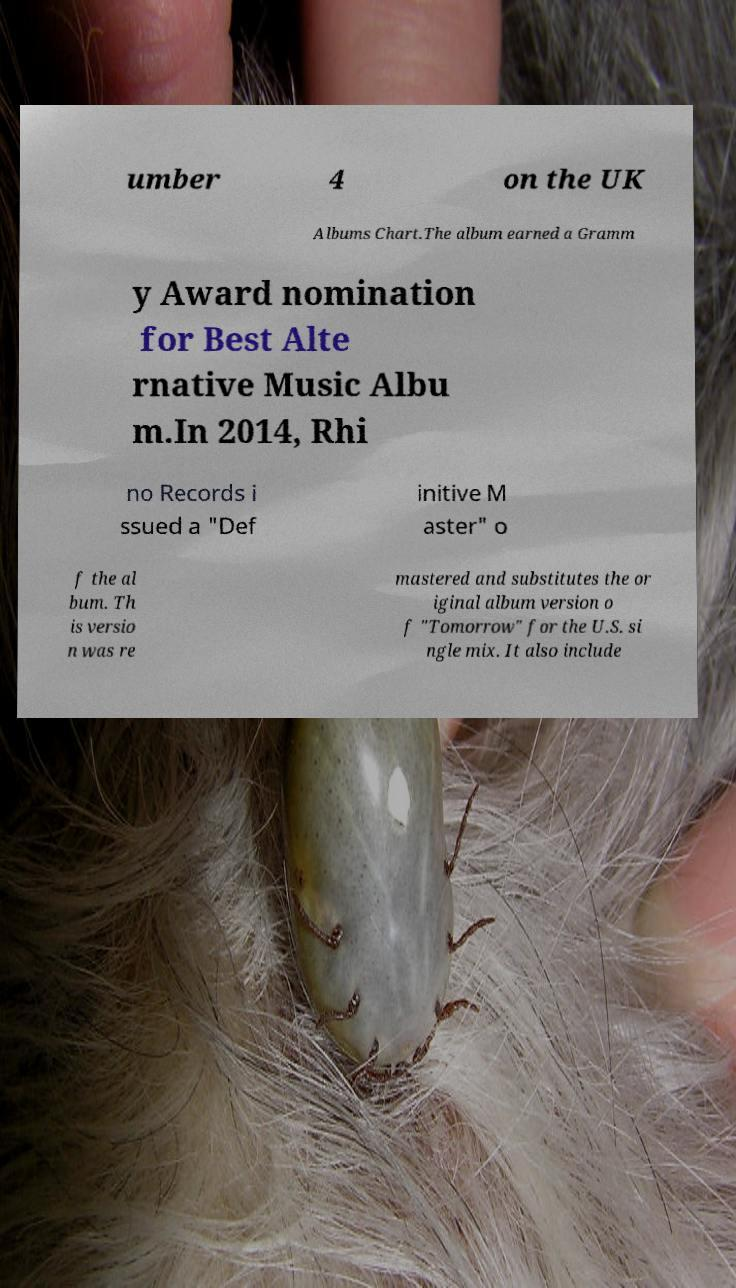Could you extract and type out the text from this image? umber 4 on the UK Albums Chart.The album earned a Gramm y Award nomination for Best Alte rnative Music Albu m.In 2014, Rhi no Records i ssued a "Def initive M aster" o f the al bum. Th is versio n was re mastered and substitutes the or iginal album version o f "Tomorrow" for the U.S. si ngle mix. It also include 